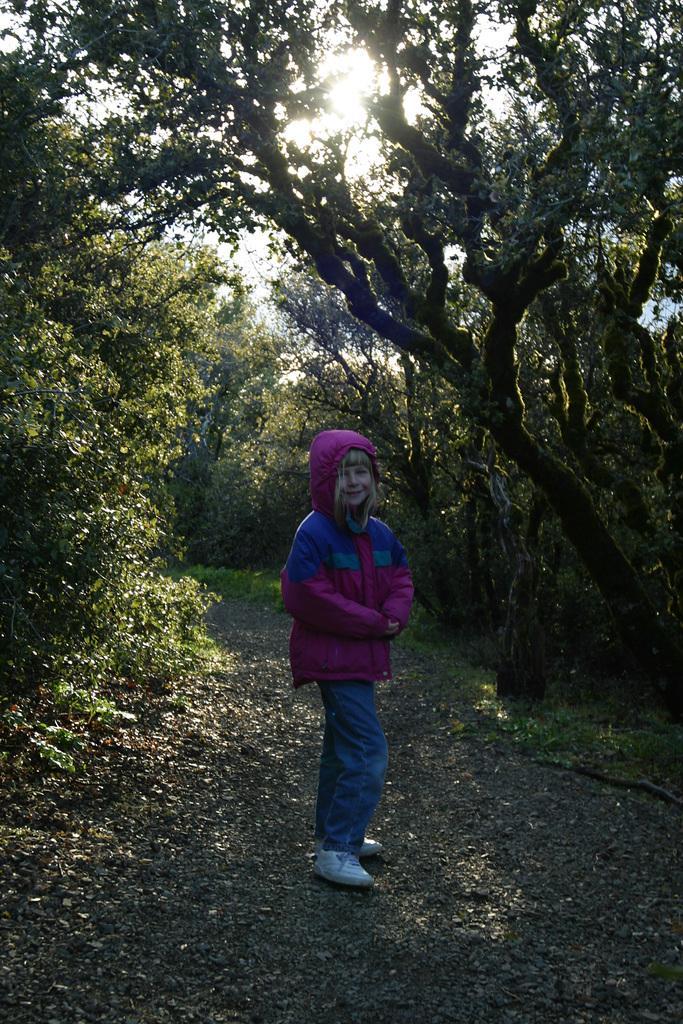In one or two sentences, can you explain what this image depicts? In this image I can see a kid is standing, this kid wore purple color coat, blue color trouser. There are trees in this image. 